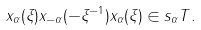Convert formula to latex. <formula><loc_0><loc_0><loc_500><loc_500>x _ { \alpha } ( \xi ) x _ { - \alpha } ( - \xi ^ { - 1 } ) x _ { \alpha } ( \xi ) \in s _ { \alpha } T .</formula> 